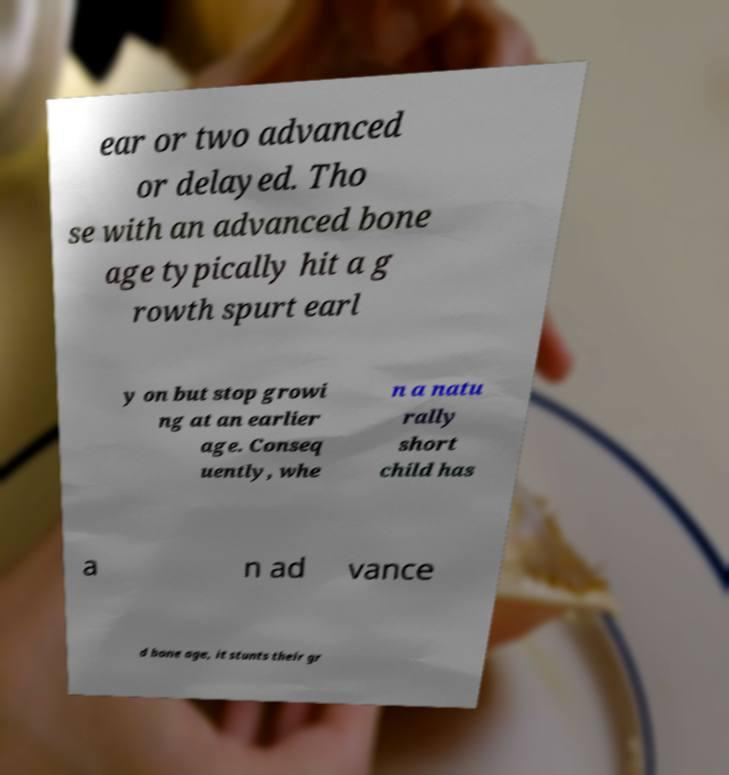Can you read and provide the text displayed in the image?This photo seems to have some interesting text. Can you extract and type it out for me? ear or two advanced or delayed. Tho se with an advanced bone age typically hit a g rowth spurt earl y on but stop growi ng at an earlier age. Conseq uently, whe n a natu rally short child has a n ad vance d bone age, it stunts their gr 